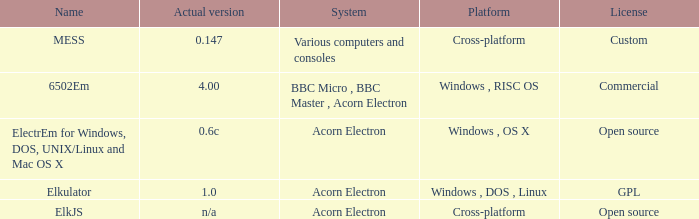What is the appellation of the platform used for assorted computers and consoles? Cross-platform. 